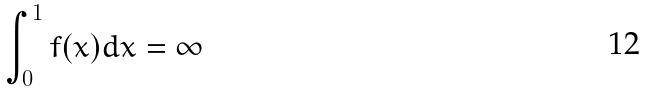<formula> <loc_0><loc_0><loc_500><loc_500>\int _ { 0 } ^ { 1 } f ( x ) d x = \infty</formula> 